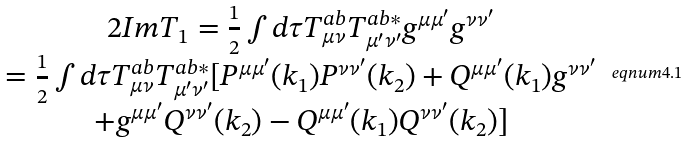<formula> <loc_0><loc_0><loc_500><loc_500>\begin{array} { c } 2 I m T _ { 1 } = \frac { 1 } { 2 } \int d \tau T _ { \mu \nu } ^ { a b } T _ { \mu ^ { \prime } \nu ^ { \prime } } ^ { a b * } g ^ { \mu \mu ^ { \prime } } g ^ { \nu \nu ^ { \prime } } \\ = \frac { 1 } { 2 } \int d \tau T _ { \mu \nu } ^ { a b } T _ { \mu ^ { \prime } \nu ^ { \prime } } ^ { a b * } [ P ^ { \mu \mu ^ { \prime } } ( k _ { 1 } ) P ^ { \nu \nu ^ { \prime } } ( k _ { 2 } ) + Q ^ { \mu \mu ^ { \prime } } ( k _ { 1 } ) g ^ { \nu \nu ^ { \prime } } \\ + g ^ { \mu \mu ^ { \prime } } Q ^ { \nu \nu ^ { \prime } } ( k _ { 2 } ) - Q ^ { \mu \mu ^ { \prime } } ( k _ { 1 } ) Q ^ { \nu \nu ^ { \prime } } ( k _ { 2 } ) ] \end{array} \ e q n u m { 4 . 1 }</formula> 